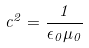<formula> <loc_0><loc_0><loc_500><loc_500>c ^ { 2 } = \frac { 1 } { \epsilon _ { 0 } \mu _ { 0 } }</formula> 